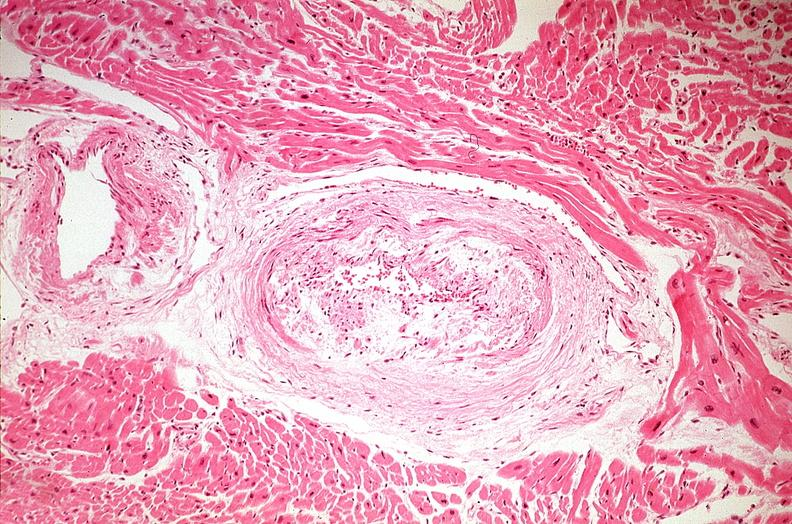s cardiovascular present?
Answer the question using a single word or phrase. Yes 